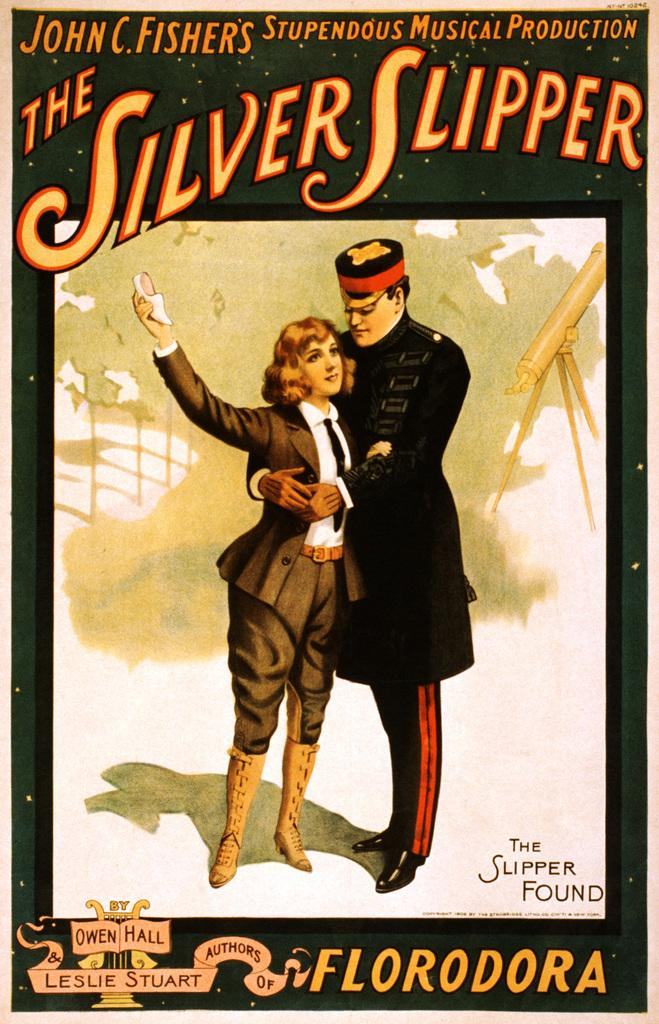<image>
Summarize the visual content of the image. The musical production The Silver Slipper is the work of John C. Fishers. 